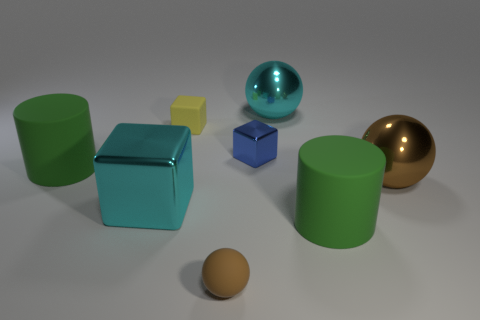There is a big ball that is the same color as the tiny rubber ball; what is its material?
Offer a very short reply. Metal. What number of shiny objects are either tiny cylinders or large brown spheres?
Provide a succinct answer. 1. There is a brown metal ball; how many rubber objects are behind it?
Your response must be concise. 2. Is there a blue cube that has the same size as the brown shiny object?
Make the answer very short. No. Are there any big shiny spheres of the same color as the matte cube?
Ensure brevity in your answer.  No. Is there any other thing that has the same size as the yellow block?
Provide a succinct answer. Yes. What number of other big cubes are the same color as the large metal cube?
Your response must be concise. 0. There is a large block; does it have the same color as the big cylinder left of the small brown ball?
Ensure brevity in your answer.  No. What number of objects are either small blue metal blocks or matte things in front of the yellow matte cube?
Make the answer very short. 4. There is a sphere that is in front of the large metal ball in front of the small yellow rubber object; what size is it?
Make the answer very short. Small. 